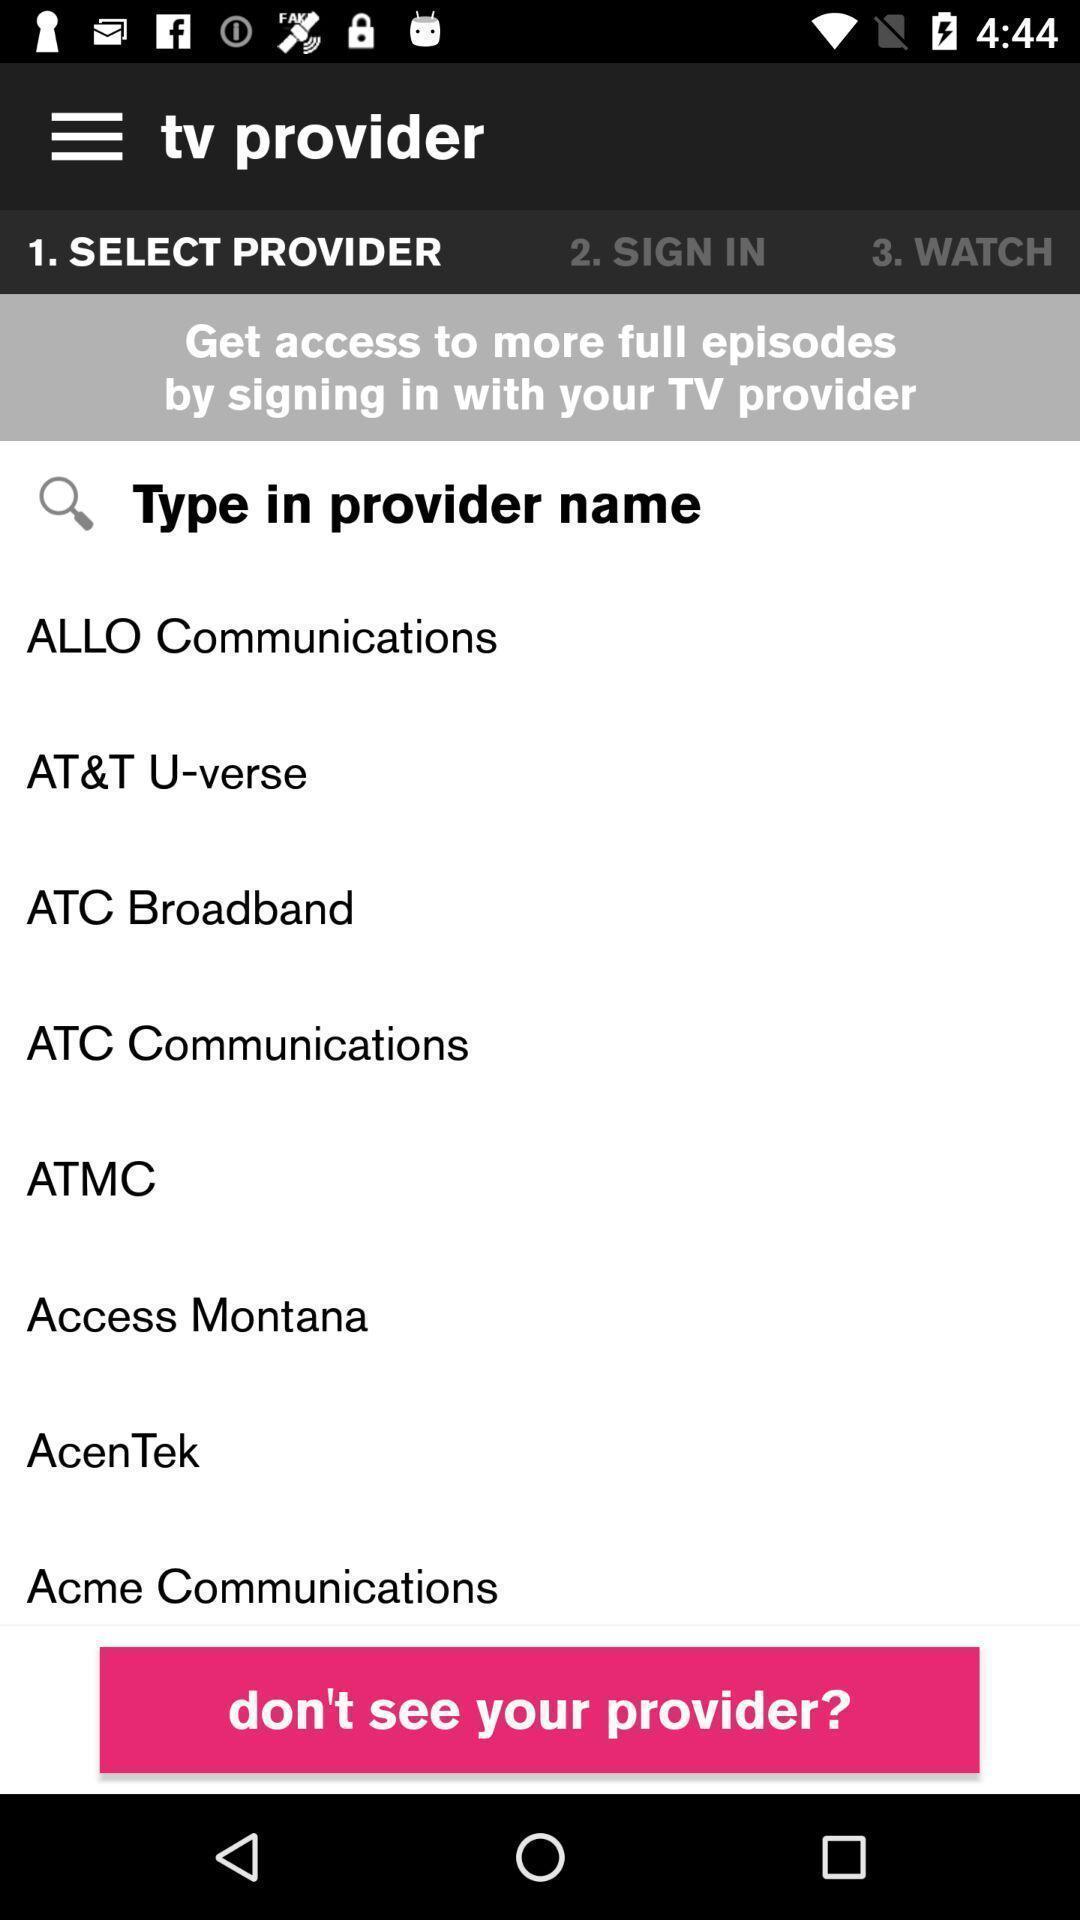What can you discern from this picture? Various providers page displayed in a tv streaming app. 